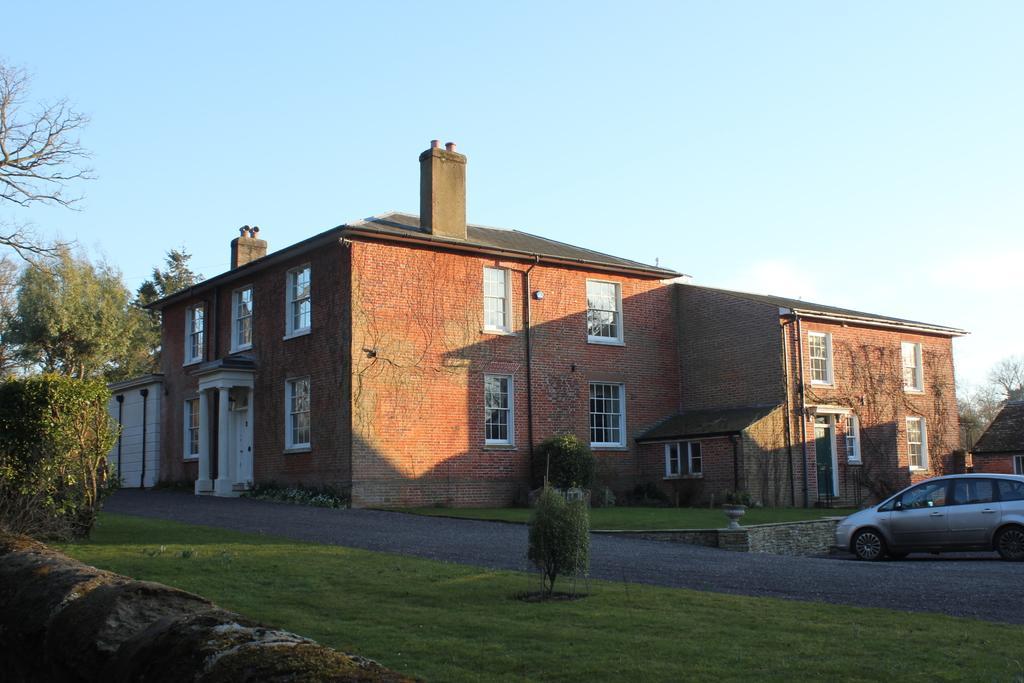Please provide a concise description of this image. This is grass and there is a car on the road. Here we can see plants, trees, and buildings. In the background there is sky. 